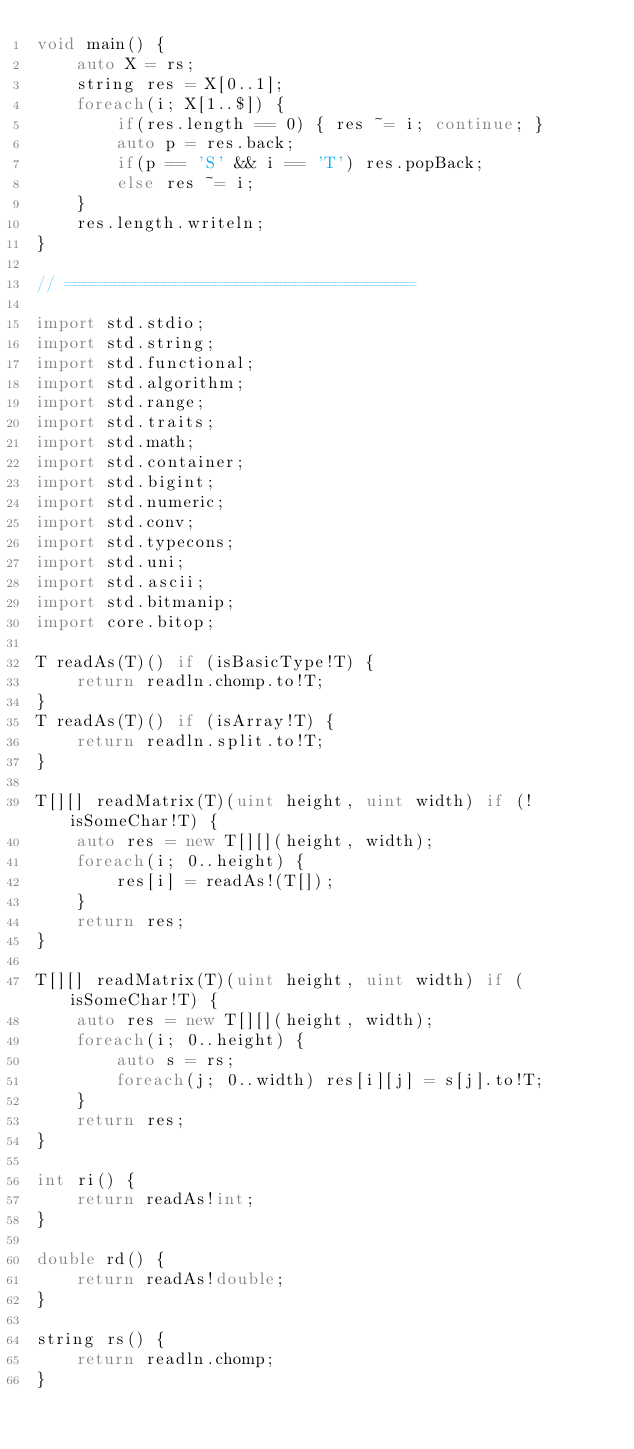<code> <loc_0><loc_0><loc_500><loc_500><_D_>void main() {
	auto X = rs;
	string res = X[0..1];
	foreach(i; X[1..$]) {
		if(res.length == 0) { res ~= i; continue; }
		auto p = res.back;
		if(p == 'S' && i == 'T') res.popBack;
		else res ~= i;
	}
	res.length.writeln;
}

// ===================================

import std.stdio;
import std.string;
import std.functional;
import std.algorithm;
import std.range;
import std.traits;
import std.math;
import std.container;
import std.bigint;
import std.numeric;
import std.conv;
import std.typecons;
import std.uni;
import std.ascii;
import std.bitmanip;
import core.bitop;

T readAs(T)() if (isBasicType!T) {
	return readln.chomp.to!T;
}
T readAs(T)() if (isArray!T) {
	return readln.split.to!T;
}

T[][] readMatrix(T)(uint height, uint width) if (!isSomeChar!T) {
	auto res = new T[][](height, width);
	foreach(i; 0..height) {
		res[i] = readAs!(T[]);
	}
	return res;
}

T[][] readMatrix(T)(uint height, uint width) if (isSomeChar!T) {
	auto res = new T[][](height, width);
	foreach(i; 0..height) {
		auto s = rs;
		foreach(j; 0..width) res[i][j] = s[j].to!T;
	}
	return res;
}

int ri() {
	return readAs!int;
}

double rd() {
	return readAs!double;
}

string rs() {
	return readln.chomp;
}
</code> 